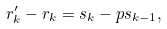Convert formula to latex. <formula><loc_0><loc_0><loc_500><loc_500>r _ { k } ^ { \prime } - r _ { k } = s _ { k } - p s _ { k - 1 } ,</formula> 